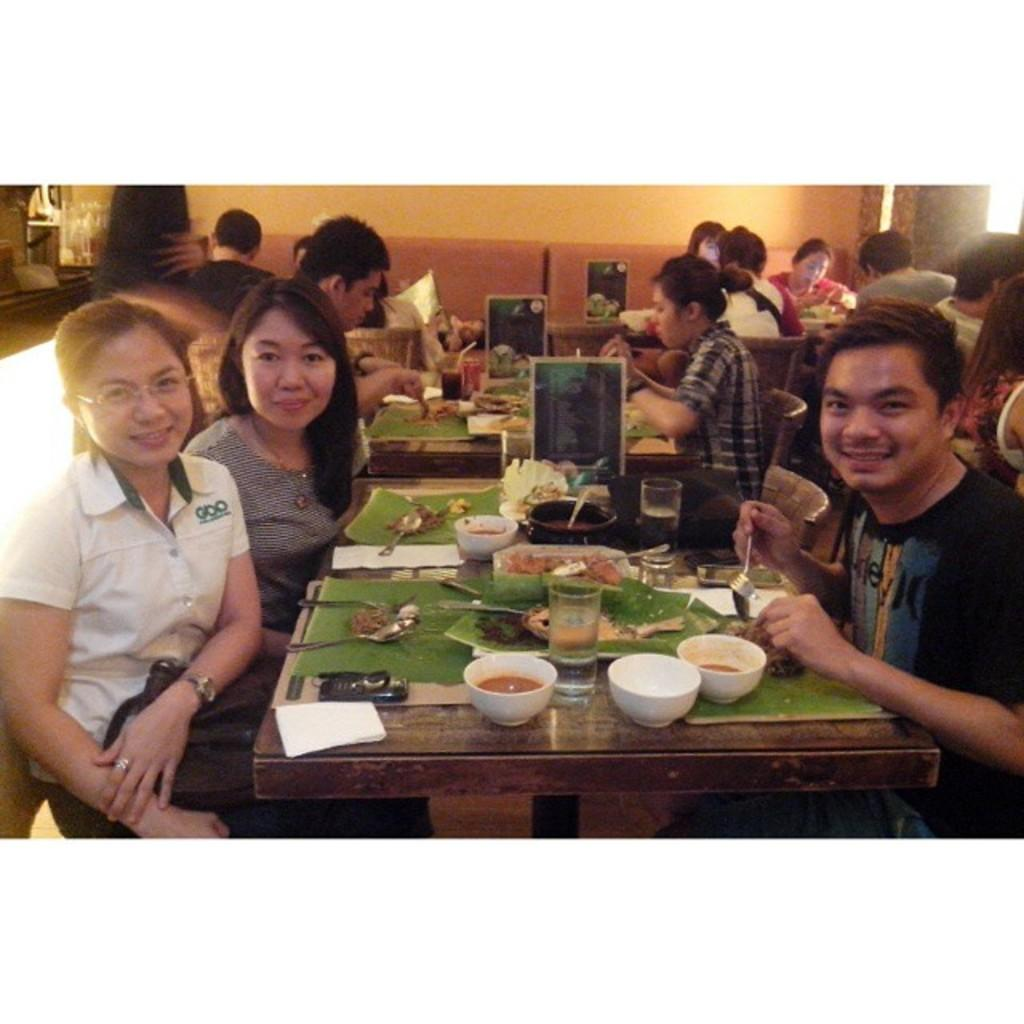What are the people in the image doing? The people in the image are sitting on chairs. Can you describe the expressions on their faces? Some people have smiles on their faces. What objects can be seen on the table in the image? There are bowls and glasses on the table in the image. Is there any dirt visible on the floor in the image? There is no mention of dirt in the provided facts, and therefore we cannot determine if it is present in the image. 